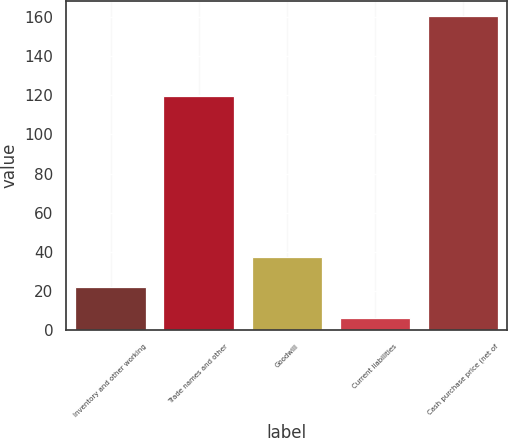<chart> <loc_0><loc_0><loc_500><loc_500><bar_chart><fcel>Inventory and other working<fcel>Trade names and other<fcel>Goodwill<fcel>Current liabilities<fcel>Cash purchase price (net of<nl><fcel>21.88<fcel>119.6<fcel>37.26<fcel>6.5<fcel>160.3<nl></chart> 